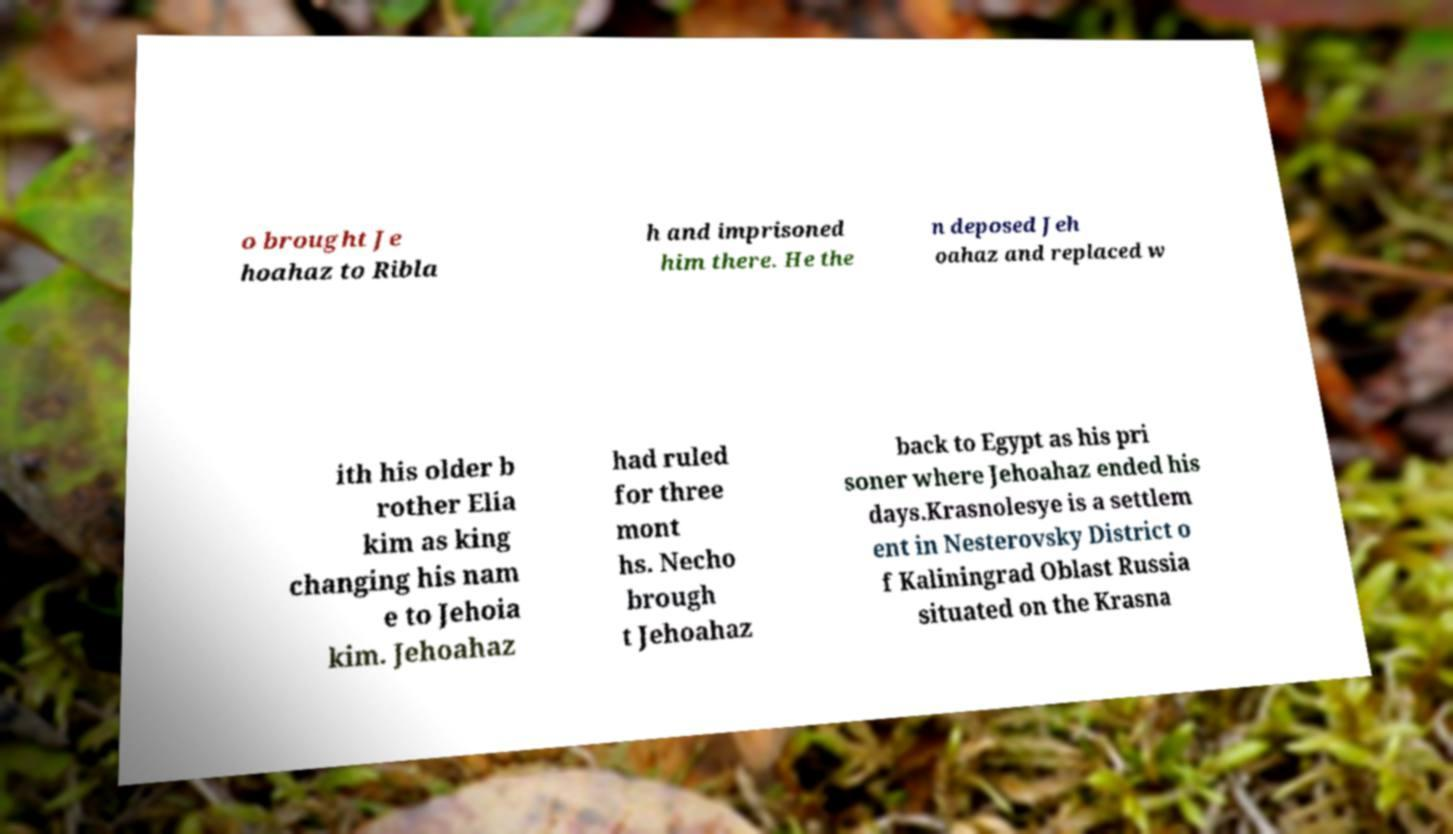I need the written content from this picture converted into text. Can you do that? o brought Je hoahaz to Ribla h and imprisoned him there. He the n deposed Jeh oahaz and replaced w ith his older b rother Elia kim as king changing his nam e to Jehoia kim. Jehoahaz had ruled for three mont hs. Necho brough t Jehoahaz back to Egypt as his pri soner where Jehoahaz ended his days.Krasnolesye is a settlem ent in Nesterovsky District o f Kaliningrad Oblast Russia situated on the Krasna 